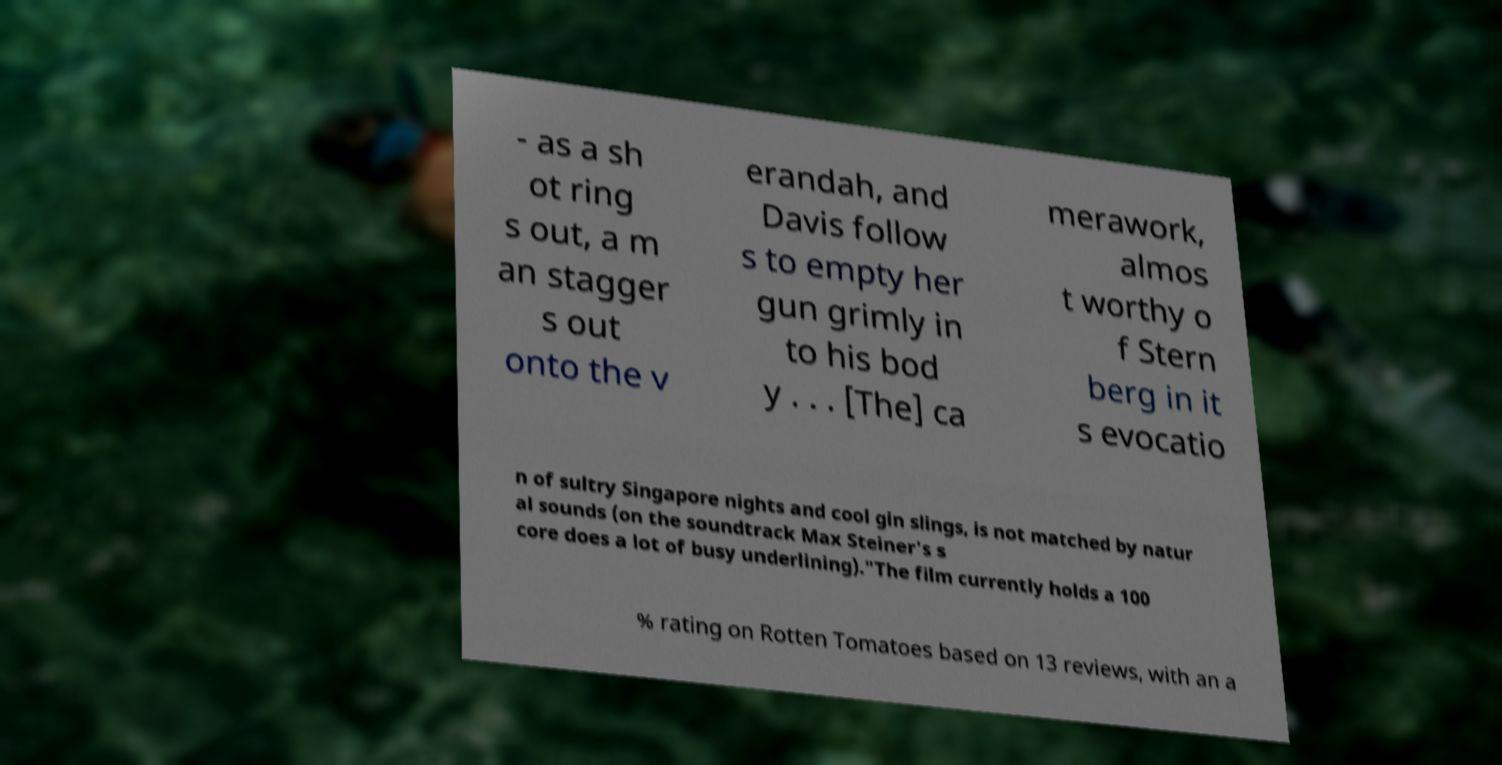I need the written content from this picture converted into text. Can you do that? - as a sh ot ring s out, a m an stagger s out onto the v erandah, and Davis follow s to empty her gun grimly in to his bod y . . . [The] ca merawork, almos t worthy o f Stern berg in it s evocatio n of sultry Singapore nights and cool gin slings, is not matched by natur al sounds (on the soundtrack Max Steiner's s core does a lot of busy underlining)."The film currently holds a 100 % rating on Rotten Tomatoes based on 13 reviews, with an a 